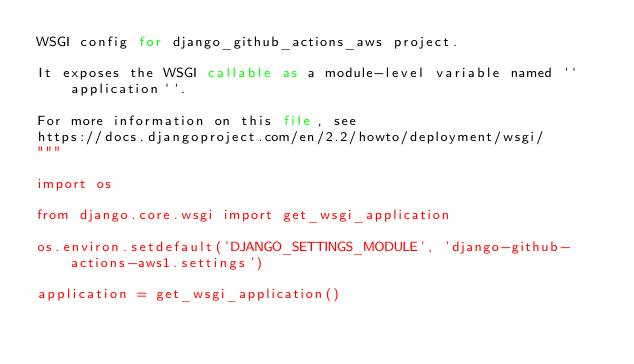Convert code to text. <code><loc_0><loc_0><loc_500><loc_500><_Python_>WSGI config for django_github_actions_aws project.

It exposes the WSGI callable as a module-level variable named ``application``.

For more information on this file, see
https://docs.djangoproject.com/en/2.2/howto/deployment/wsgi/
"""

import os

from django.core.wsgi import get_wsgi_application

os.environ.setdefault('DJANGO_SETTINGS_MODULE', 'django-github-actions-aws1.settings')

application = get_wsgi_application()
</code> 